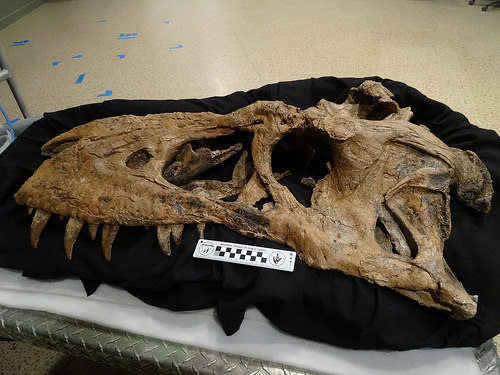<image>
Is there a dinosaur on the blanket? Yes. Looking at the image, I can see the dinosaur is positioned on top of the blanket, with the blanket providing support. 